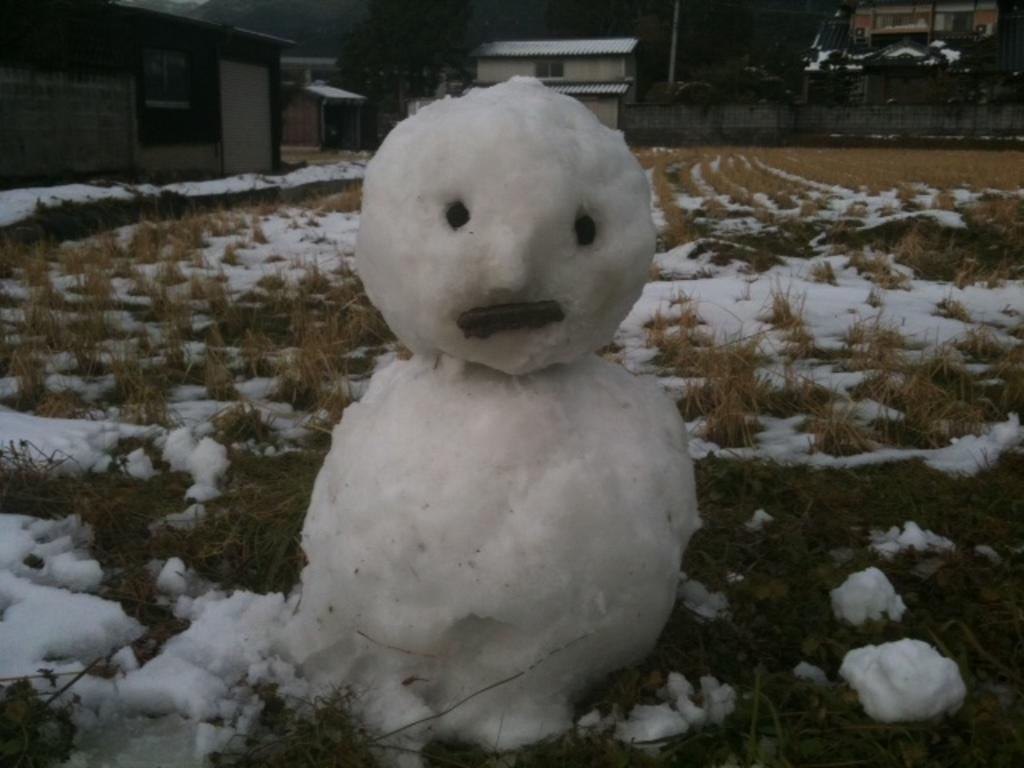What is the main subject in the image? There is a snowman in the image. What type of terrain is visible in the image? Grass is visible on the ground, and snow is present on the ground as well. What can be seen in the background of the image? There are houses, trees, and a wall in the background of the image. What type of chalk is being used to draw on the snowman? There is no chalk present in the image, and therefore no such activity can be observed. 